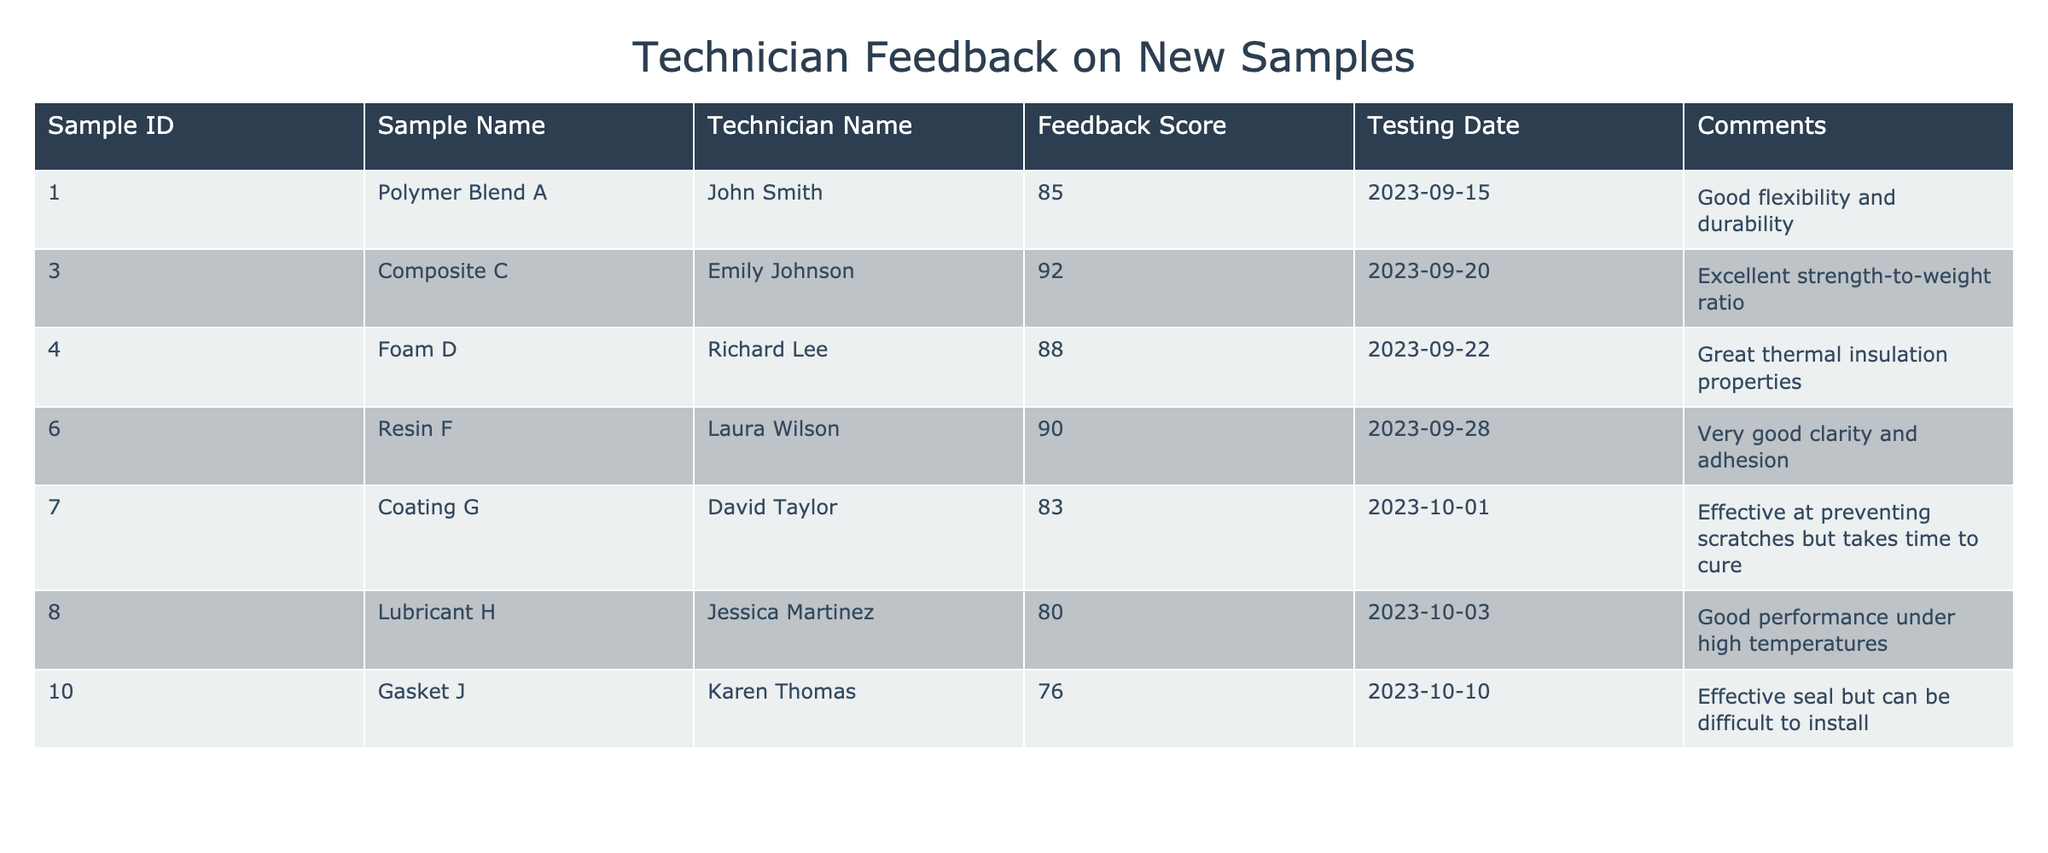What is the feedback score for Polymer Blend A? In the table, under the "Feedback Score" column for the row with "Sample Name" as Polymer Blend A, the score is listed as 85.
Answer: 85 Which technician provided the highest feedback score? Looking through the "Feedback Score" column, the highest score is 92, which is associated with Emily Johnson for Composite C.
Answer: Emily Johnson What is the average feedback score for all samples? To calculate the average, sum up all the feedback scores (85 + 92 + 88 + 90 + 83 + 80 + 76) = 504. There are 7 samples, so dividing 504 by 7 gives an average score of 72. So, the average feedback score is 504/7 = 72.
Answer: 72 Did John Smith give a feedback score lower than 90? Looking at John's feedback score for Polymer Blend A, which is 85, we can conclude it is lower than 90.
Answer: Yes How many samples received a feedback score above 85? By examining the scores: Polymer Blend A (85), Composite C (92), Foam D (88), Resin F (90) are all above 85. That adds up to 4 samples with scores greater than 85.
Answer: 4 What percentage of samples scored above 80? There are 7 samples in total. The samples with scores above 80 are Composite C (92), Foam D (88), Resin F (90), and Polymer Blend A (85), which gives us 5 samples. The percentage is (5/7) * 100 = 71.43% or approximately 71% when rounded.
Answer: 71% Which sample had the lowest feedback score? Scanning through the feedback scores, Gasket J has the lowest score at 76.
Answer: Gasket J Is there a sample that received comments indicating good performance at high temperatures? Upon reviewing the comments, Lubricant H mentions "Good performance under high temperatures." Hence, this sample fits the criteria.
Answer: Yes How do the scores of Coating G and Gasket J compare? Coating G has a score of 83 while Gasket J has a score of 76. This means Coating G scored 7 points higher than Gasket J.
Answer: Coating G scored higher 